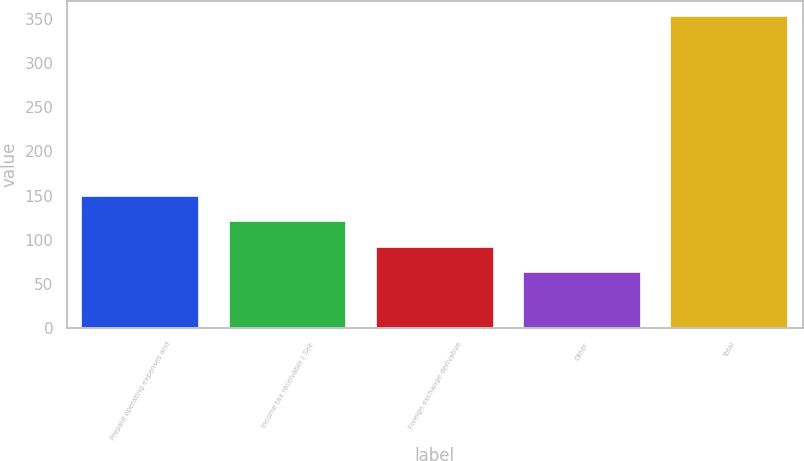Convert chart to OTSL. <chart><loc_0><loc_0><loc_500><loc_500><bar_chart><fcel>Prepaid operating expenses and<fcel>Income tax receivable ( See<fcel>Foreign exchange derivative<fcel>Other<fcel>Total<nl><fcel>150<fcel>121<fcel>92<fcel>63<fcel>353<nl></chart> 